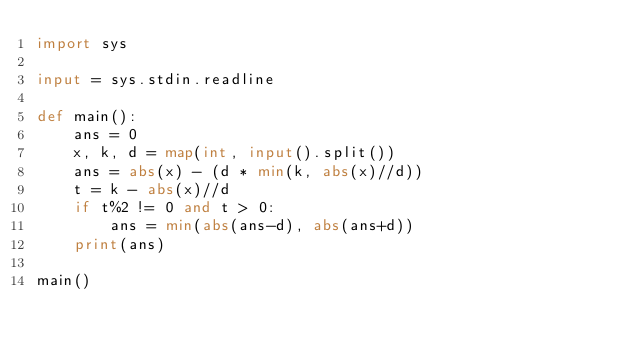<code> <loc_0><loc_0><loc_500><loc_500><_Python_>import sys

input = sys.stdin.readline

def main():
    ans = 0
    x, k, d = map(int, input().split())
    ans = abs(x) - (d * min(k, abs(x)//d))
    t = k - abs(x)//d
    if t%2 != 0 and t > 0:
        ans = min(abs(ans-d), abs(ans+d))
    print(ans)

main()

</code> 